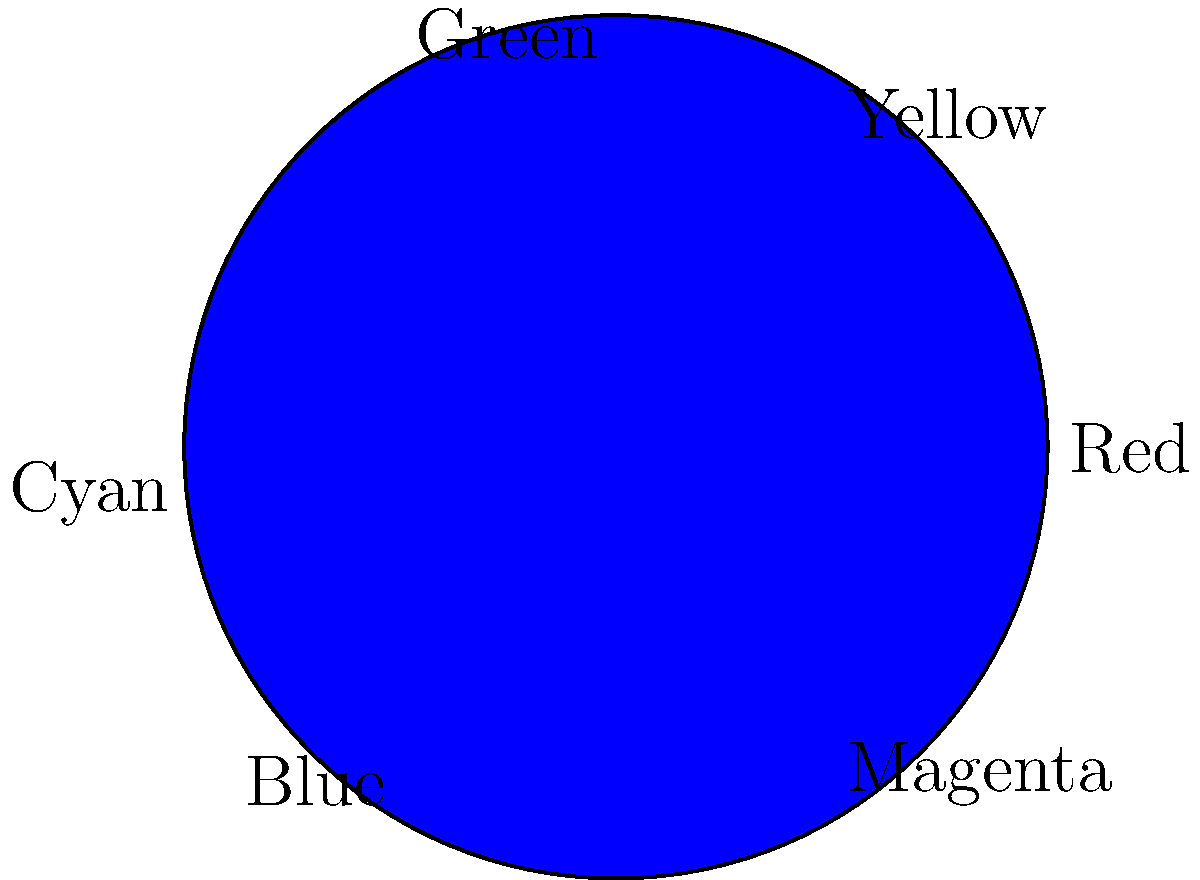As a graphic designer collaborating with Pauline, you're tasked with creating a complementary color scheme for a project. Using the color wheel provided, which color would be considered complementary to yellow? To determine the complementary color of yellow, follow these steps:

1. Locate yellow on the color wheel (between red and green).
2. Identify the color directly opposite yellow on the wheel.
3. The color opposite yellow is blue.

Complementary colors are pairs of colors that are opposite each other on the color wheel. When used together, they create high contrast and visual interest. In color theory, complementary colors are considered to be harmonious and pleasing to the eye when used in design.

As a graphic designer, understanding complementary colors is crucial for creating balanced and visually appealing designs. This knowledge can be applied in various projects, such as logo design, web design, or print materials, to create eye-catching and harmonious color schemes.
Answer: Blue 